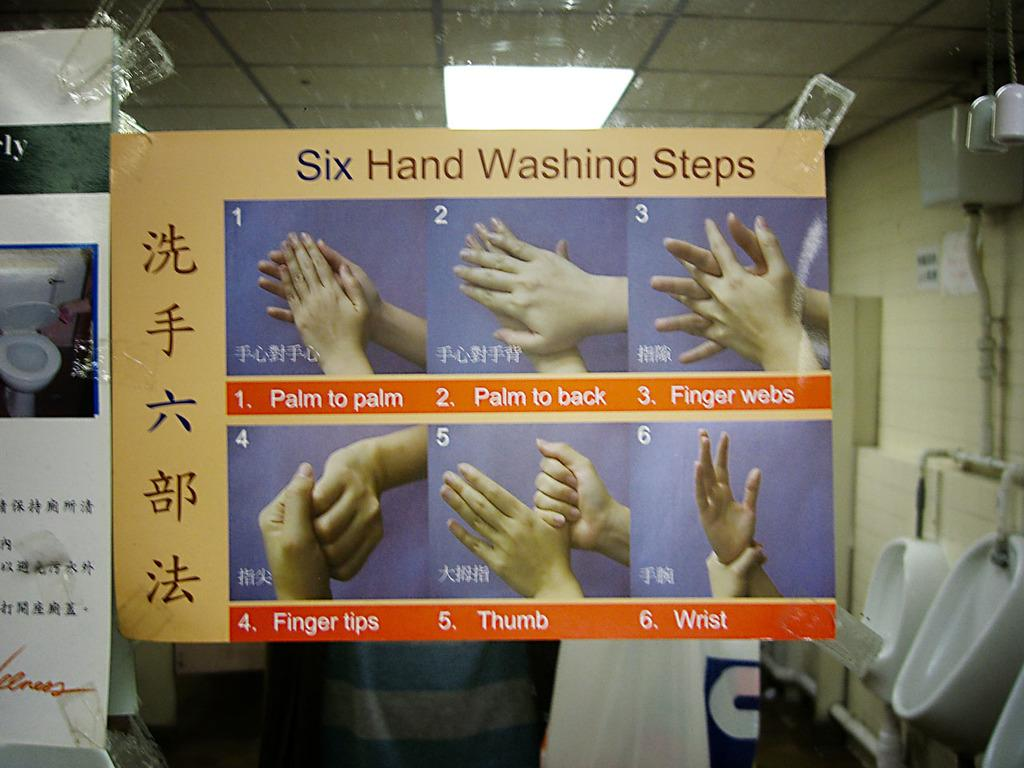<image>
Present a compact description of the photo's key features. Six hand washing steps are shown on a poster with images of hands washing. 